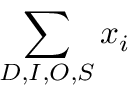Convert formula to latex. <formula><loc_0><loc_0><loc_500><loc_500>\sum _ { D , I , O , S } x _ { i }</formula> 